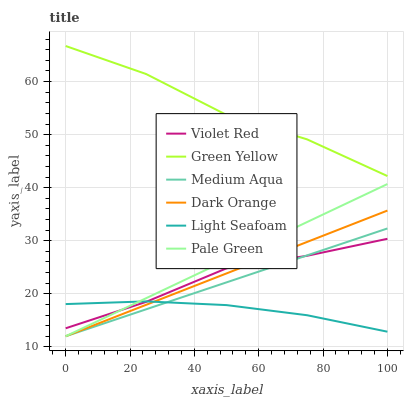Does Light Seafoam have the minimum area under the curve?
Answer yes or no. Yes. Does Green Yellow have the maximum area under the curve?
Answer yes or no. Yes. Does Violet Red have the minimum area under the curve?
Answer yes or no. No. Does Violet Red have the maximum area under the curve?
Answer yes or no. No. Is Medium Aqua the smoothest?
Answer yes or no. Yes. Is Green Yellow the roughest?
Answer yes or no. Yes. Is Violet Red the smoothest?
Answer yes or no. No. Is Violet Red the roughest?
Answer yes or no. No. Does Dark Orange have the lowest value?
Answer yes or no. Yes. Does Violet Red have the lowest value?
Answer yes or no. No. Does Green Yellow have the highest value?
Answer yes or no. Yes. Does Violet Red have the highest value?
Answer yes or no. No. Is Pale Green less than Green Yellow?
Answer yes or no. Yes. Is Green Yellow greater than Light Seafoam?
Answer yes or no. Yes. Does Violet Red intersect Pale Green?
Answer yes or no. Yes. Is Violet Red less than Pale Green?
Answer yes or no. No. Is Violet Red greater than Pale Green?
Answer yes or no. No. Does Pale Green intersect Green Yellow?
Answer yes or no. No. 